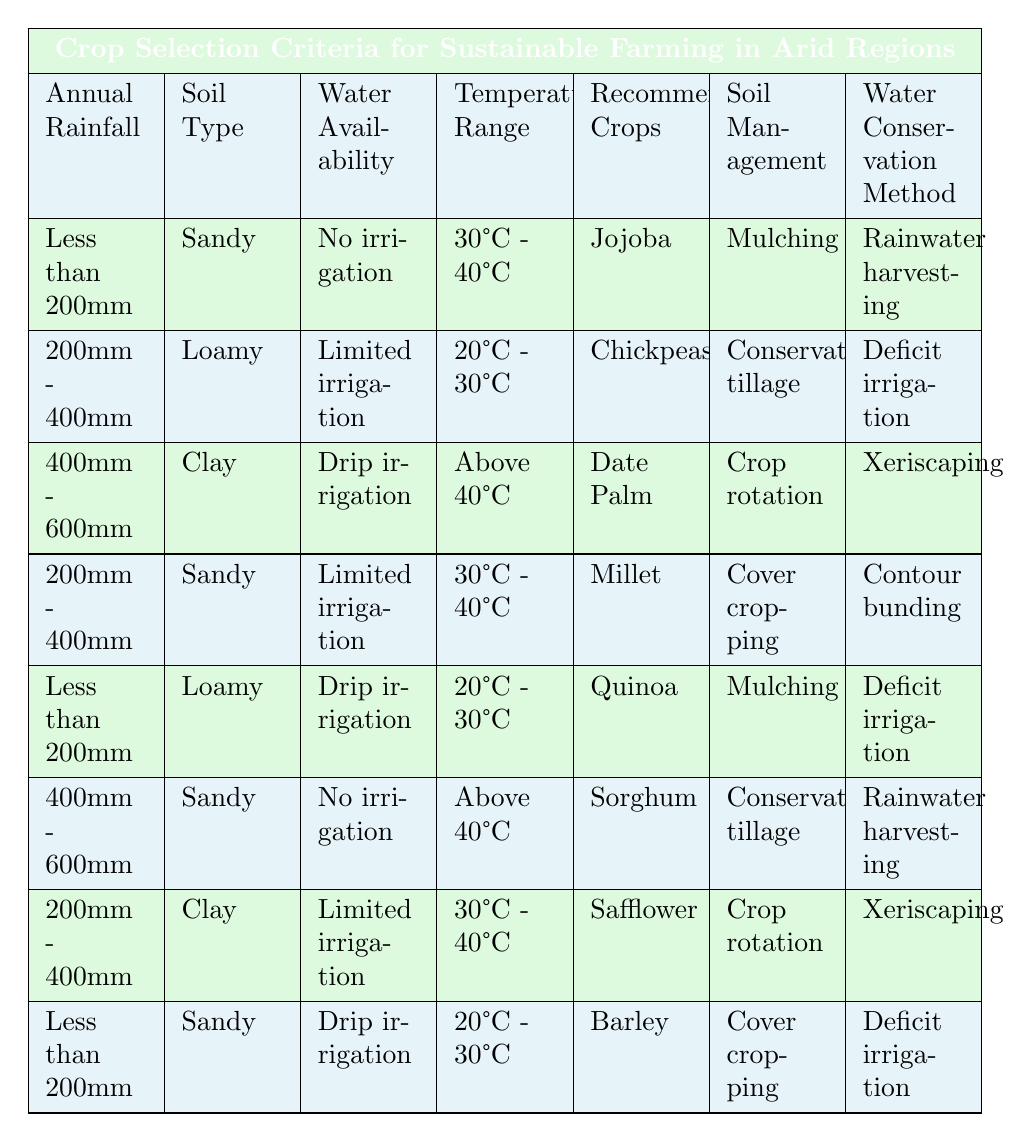What recommended crops are suitable for sandy soil with less than 200mm rainfall and temperatures between 30°C and 40°C? In the table, find the row with "Sandy" as the soil type, "Less than 200mm" as the rainfall, and "30°C - 40°C" as the temperature range. The crops listed in that row are "Jojoba."
Answer: Jojoba Which water conservation method is recommended for millets grown in sandy soil with limited irrigation and temperatures between 30°C and 40°C? Locate the row that has "Sandy" soil, "Limited irrigation" for water availability, and "30°C - 40°C" temperature. The corresponding water conservation method listed is "Contour bunding."
Answer: Contour bunding True or False: Chickpeas can be grown under loamy soil conditions with annual rainfall between 200mm and 400mm when temperatures are between 20°C and 30°C. The table indicates that for loamy soil conditions with rainfall between 200mm and 400mm and temperatures between 20°C and 30°C, "Chickpeas" are indeed listed as a recommended crop, so the statement is true.
Answer: True What is the average annual rainfall for the recommended crops listed in the table that utilize drip irrigation? Focus on the rows where "Drip irrigation" is noted for water availability. The corresponding annual rainfalls are "400mm - 600mm" (Date Palm) and "Less than 200mm" (Quinoa). Convert these ranges to numerical values for average: (400 + 200) / 2 = 300mm is a rough estimate. The average values should be considered only if clarified as midpoints; nevertheless, in this case, it primarily reflects values above 200mm rather than the average to provide a general overview.
Answer: Approximately 300mm Identify the crops and soil management method recommended for clay soil with limited irrigation and temperatures in the range of 30°C to 40°C. In the table, search for clay soil, limited irrigation, and 30°C to 40°C. The row that fulfills these conditions lists "Safflower" as the crop and "Crop rotation" as the soil management method.
Answer: Safflower, Crop rotation 